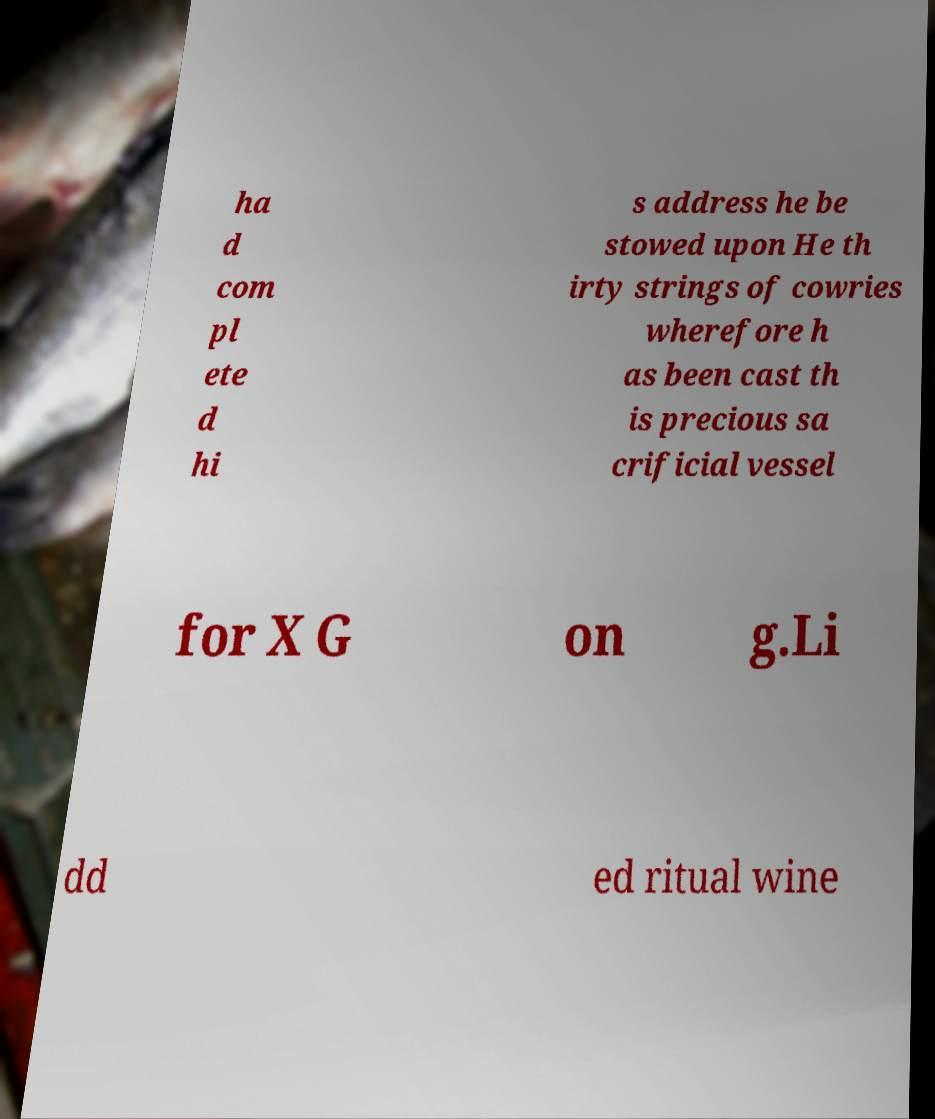Can you accurately transcribe the text from the provided image for me? ha d com pl ete d hi s address he be stowed upon He th irty strings of cowries wherefore h as been cast th is precious sa crificial vessel for X G on g.Li dd ed ritual wine 